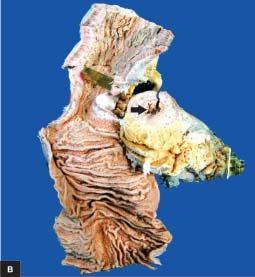how does luminal surface of longitudinal cut section show segment of thickened wall?
Answer the question using a single word or phrase. With narrow lumen 